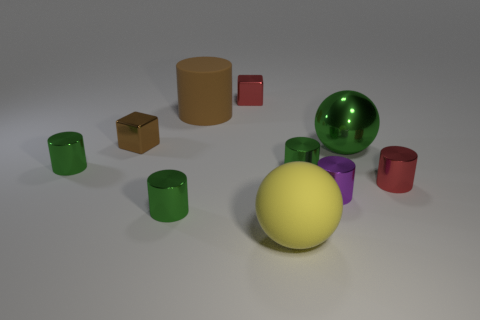How many green cylinders must be subtracted to get 1 green cylinders? 2 Subtract all big brown cylinders. How many cylinders are left? 5 Subtract all green blocks. How many green cylinders are left? 3 Subtract 3 cylinders. How many cylinders are left? 3 Subtract all purple cylinders. How many cylinders are left? 5 Subtract all metallic balls. Subtract all yellow rubber cubes. How many objects are left? 9 Add 2 spheres. How many spheres are left? 4 Add 1 large matte things. How many large matte things exist? 3 Subtract 0 purple blocks. How many objects are left? 10 Subtract all balls. How many objects are left? 8 